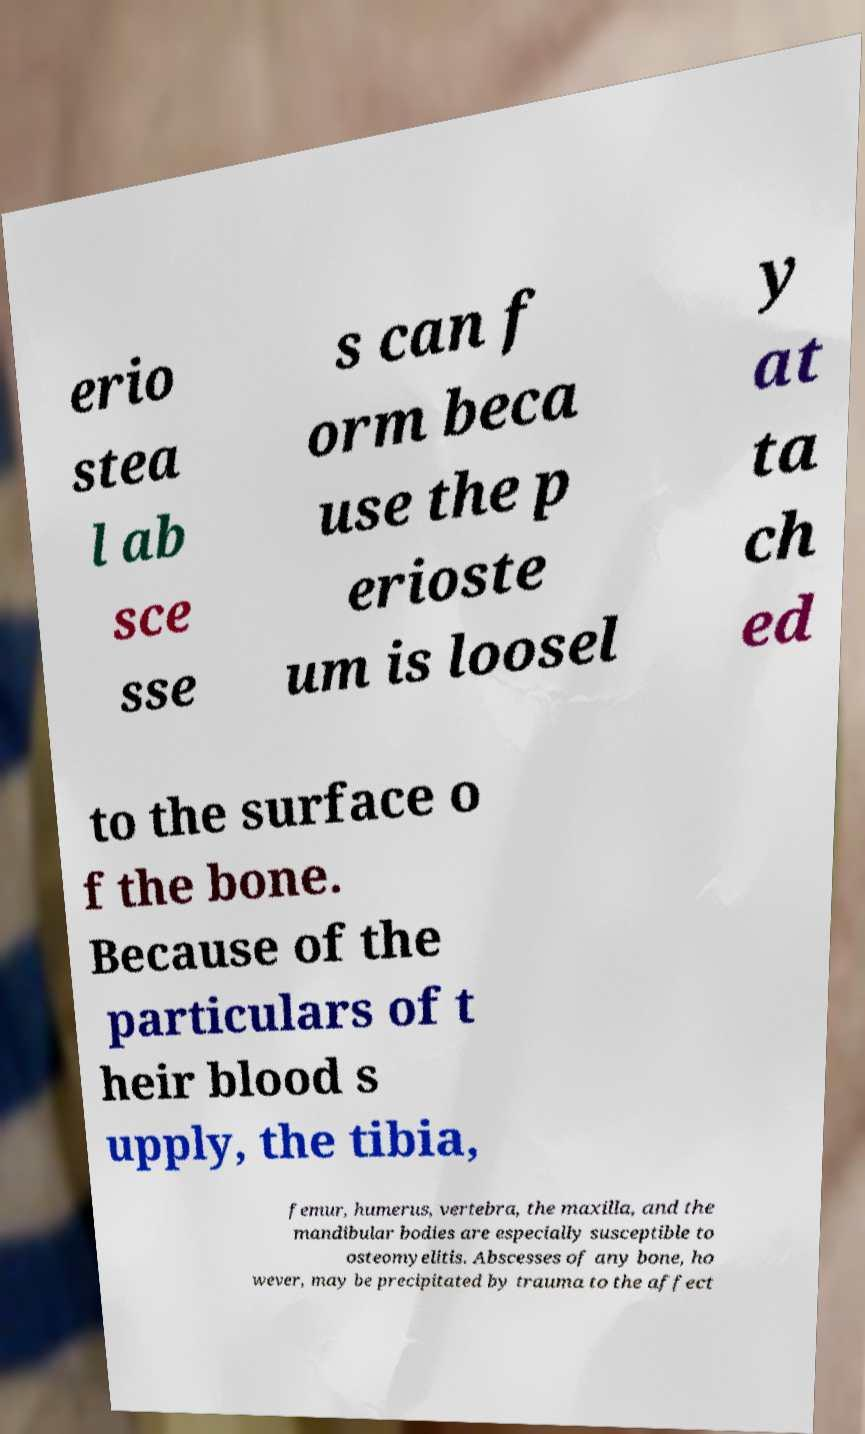What messages or text are displayed in this image? I need them in a readable, typed format. erio stea l ab sce sse s can f orm beca use the p erioste um is loosel y at ta ch ed to the surface o f the bone. Because of the particulars of t heir blood s upply, the tibia, femur, humerus, vertebra, the maxilla, and the mandibular bodies are especially susceptible to osteomyelitis. Abscesses of any bone, ho wever, may be precipitated by trauma to the affect 